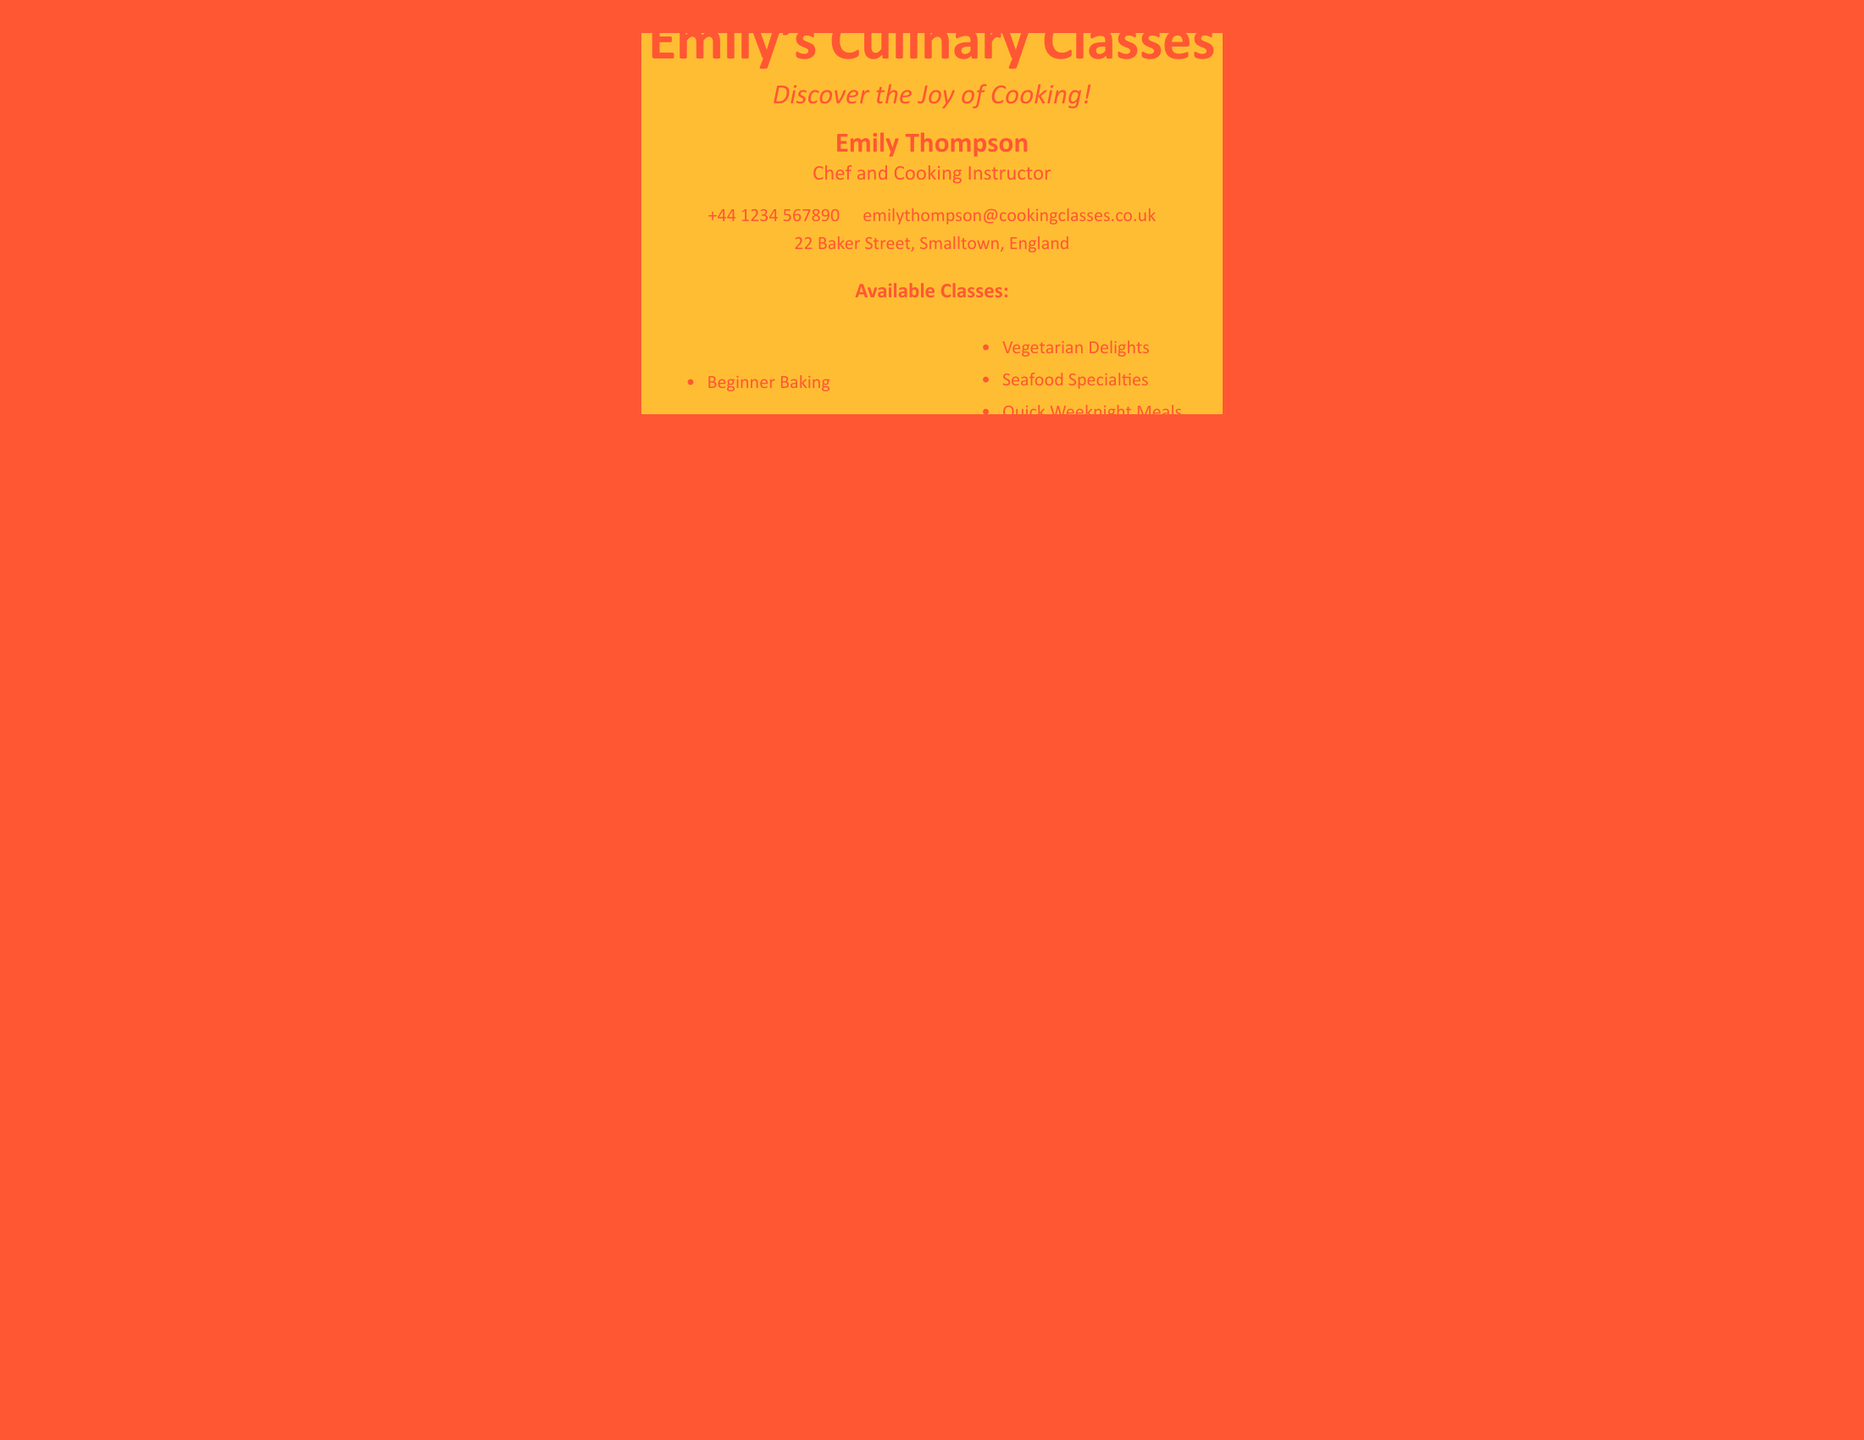What is the name of the cooking class provider? The name of the cooking class provider is prominently displayed at the top of the card.
Answer: Emily's Culinary Classes Who is the chef and cooking instructor? The name of the chef and cooking instructor is stated below the class name.
Answer: Emily Thompson How can someone contact Emily's Culinary Classes? The contact details are provided in the footer of the business card.
Answer: +44 1234 567890 What is one of the available classes? The available classes are listed in bullet points.
Answer: Beginner Baking How many classes are listed on the card? The classes are separated into sections, and the total number can be counted easily.
Answer: Five What color is the page background? The page background color is specified at the beginning of the document.
Answer: Vibrant orange In which town is the cooking class located? The location of the cooking classes is mentioned towards the bottom of the card.
Answer: Smalltown What type of cuisine is covered in one of the classes? The types of cuisine are listed as part of the available classes.
Answer: Seafood Specialties What is the emphasis of the cooking classes? The subheading gives an idea about the focus or feel of the classes.
Answer: Discover the Joy of Cooking! 